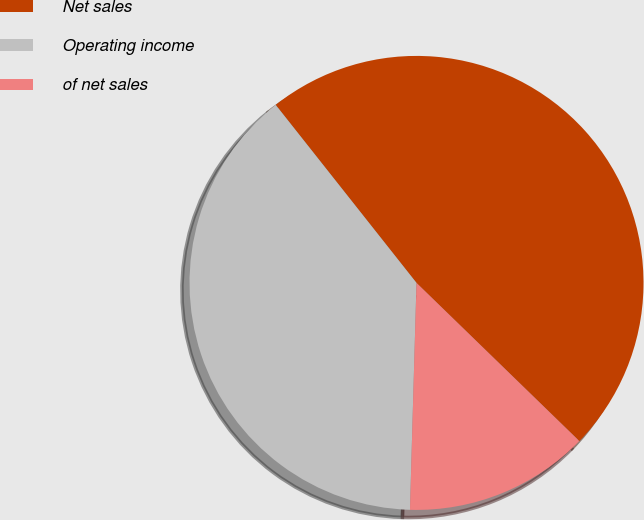Convert chart. <chart><loc_0><loc_0><loc_500><loc_500><pie_chart><fcel>Net sales<fcel>Operating income<fcel>of net sales<nl><fcel>47.92%<fcel>38.89%<fcel>13.19%<nl></chart> 